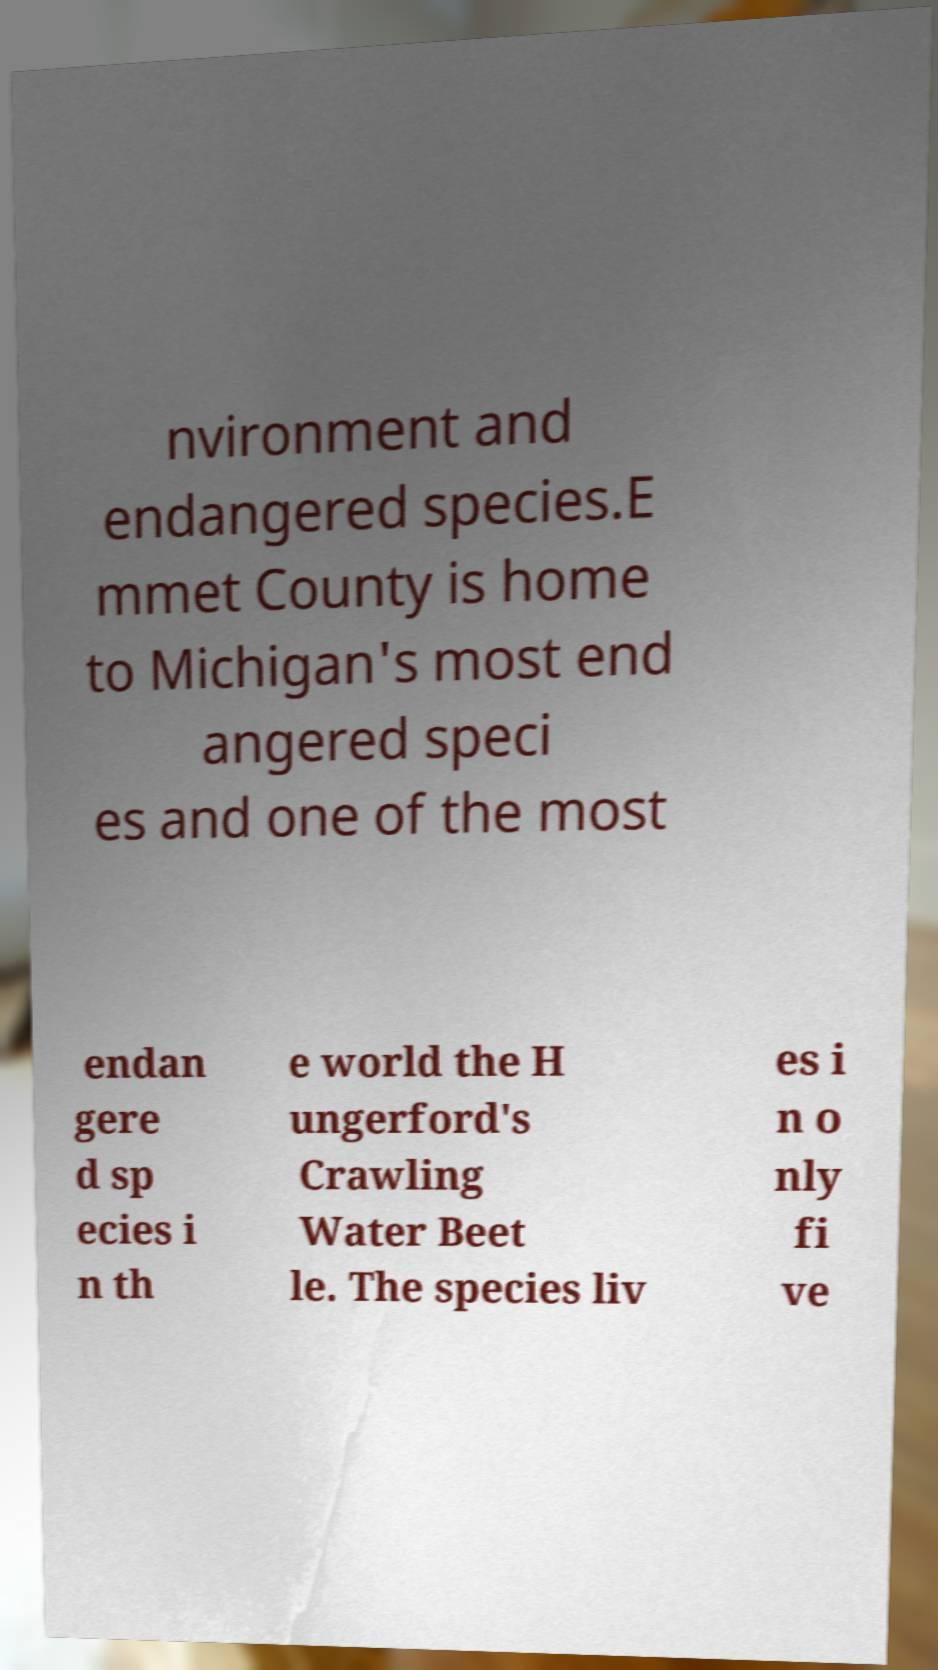What messages or text are displayed in this image? I need them in a readable, typed format. nvironment and endangered species.E mmet County is home to Michigan's most end angered speci es and one of the most endan gere d sp ecies i n th e world the H ungerford's Crawling Water Beet le. The species liv es i n o nly fi ve 